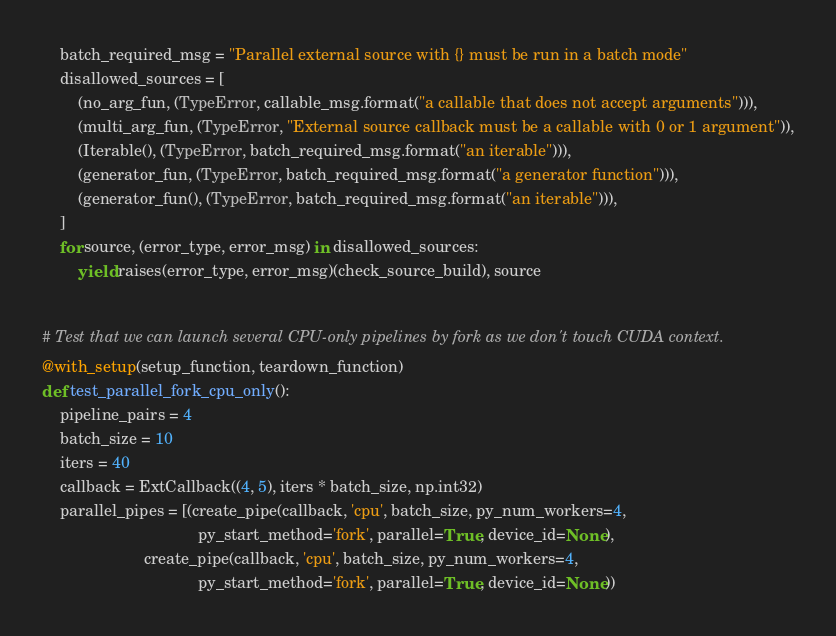Convert code to text. <code><loc_0><loc_0><loc_500><loc_500><_Python_>    batch_required_msg = "Parallel external source with {} must be run in a batch mode"
    disallowed_sources = [
        (no_arg_fun, (TypeError, callable_msg.format("a callable that does not accept arguments"))),
        (multi_arg_fun, (TypeError, "External source callback must be a callable with 0 or 1 argument")),
        (Iterable(), (TypeError, batch_required_msg.format("an iterable"))),
        (generator_fun, (TypeError, batch_required_msg.format("a generator function"))),
        (generator_fun(), (TypeError, batch_required_msg.format("an iterable"))),
    ]
    for source, (error_type, error_msg) in disallowed_sources:
        yield raises(error_type, error_msg)(check_source_build), source


# Test that we can launch several CPU-only pipelines by fork as we don't touch CUDA context.
@with_setup(setup_function, teardown_function)
def test_parallel_fork_cpu_only():
    pipeline_pairs = 4
    batch_size = 10
    iters = 40
    callback = ExtCallback((4, 5), iters * batch_size, np.int32)
    parallel_pipes = [(create_pipe(callback, 'cpu', batch_size, py_num_workers=4,
                                   py_start_method='fork', parallel=True, device_id=None),
                       create_pipe(callback, 'cpu', batch_size, py_num_workers=4,
                                   py_start_method='fork', parallel=True, device_id=None))</code> 